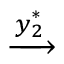<formula> <loc_0><loc_0><loc_500><loc_500>\xrightarrow { y _ { 2 } ^ { * } }</formula> 